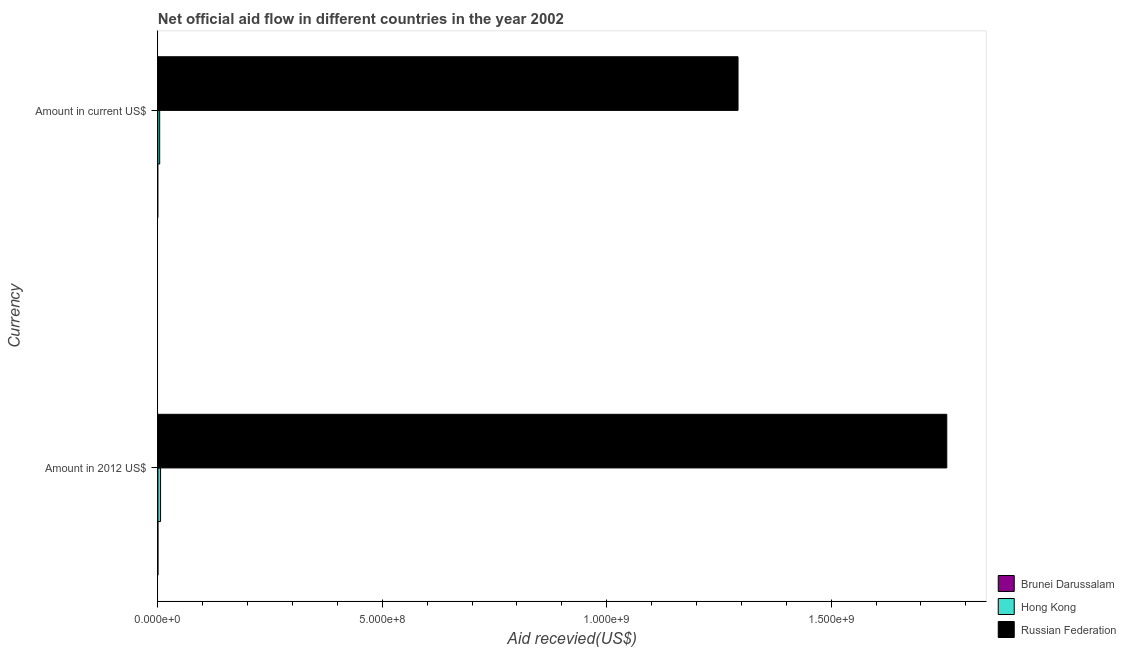What is the label of the 1st group of bars from the top?
Give a very brief answer. Amount in current US$. What is the amount of aid received(expressed in us$) in Brunei Darussalam?
Ensure brevity in your answer.  0. Across all countries, what is the maximum amount of aid received(expressed in us$)?
Ensure brevity in your answer.  1.29e+09. Across all countries, what is the minimum amount of aid received(expressed in 2012 us$)?
Provide a short and direct response. 0. In which country was the amount of aid received(expressed in 2012 us$) maximum?
Your response must be concise. Russian Federation. What is the total amount of aid received(expressed in us$) in the graph?
Make the answer very short. 1.30e+09. What is the difference between the amount of aid received(expressed in 2012 us$) in Hong Kong and that in Russian Federation?
Provide a succinct answer. -1.75e+09. What is the difference between the amount of aid received(expressed in us$) in Hong Kong and the amount of aid received(expressed in 2012 us$) in Russian Federation?
Offer a terse response. -1.75e+09. What is the average amount of aid received(expressed in us$) per country?
Your answer should be very brief. 4.32e+08. What is the difference between the amount of aid received(expressed in 2012 us$) and amount of aid received(expressed in us$) in Hong Kong?
Provide a succinct answer. 1.96e+06. What is the ratio of the amount of aid received(expressed in us$) in Hong Kong to that in Russian Federation?
Keep it short and to the point. 0. In how many countries, is the amount of aid received(expressed in 2012 us$) greater than the average amount of aid received(expressed in 2012 us$) taken over all countries?
Provide a short and direct response. 1. Are all the bars in the graph horizontal?
Provide a short and direct response. Yes. Are the values on the major ticks of X-axis written in scientific E-notation?
Your response must be concise. Yes. Does the graph contain any zero values?
Make the answer very short. Yes. Does the graph contain grids?
Keep it short and to the point. No. How many legend labels are there?
Ensure brevity in your answer.  3. How are the legend labels stacked?
Your answer should be very brief. Vertical. What is the title of the graph?
Provide a succinct answer. Net official aid flow in different countries in the year 2002. Does "Bhutan" appear as one of the legend labels in the graph?
Offer a terse response. No. What is the label or title of the X-axis?
Keep it short and to the point. Aid recevied(US$). What is the label or title of the Y-axis?
Keep it short and to the point. Currency. What is the Aid recevied(US$) in Brunei Darussalam in Amount in 2012 US$?
Your answer should be compact. 0. What is the Aid recevied(US$) in Hong Kong in Amount in 2012 US$?
Offer a very short reply. 5.92e+06. What is the Aid recevied(US$) in Russian Federation in Amount in 2012 US$?
Give a very brief answer. 1.76e+09. What is the Aid recevied(US$) in Hong Kong in Amount in current US$?
Provide a short and direct response. 3.96e+06. What is the Aid recevied(US$) of Russian Federation in Amount in current US$?
Offer a terse response. 1.29e+09. Across all Currency, what is the maximum Aid recevied(US$) in Hong Kong?
Your answer should be very brief. 5.92e+06. Across all Currency, what is the maximum Aid recevied(US$) of Russian Federation?
Offer a very short reply. 1.76e+09. Across all Currency, what is the minimum Aid recevied(US$) in Hong Kong?
Your answer should be very brief. 3.96e+06. Across all Currency, what is the minimum Aid recevied(US$) in Russian Federation?
Your answer should be very brief. 1.29e+09. What is the total Aid recevied(US$) of Hong Kong in the graph?
Offer a terse response. 9.88e+06. What is the total Aid recevied(US$) of Russian Federation in the graph?
Offer a terse response. 3.05e+09. What is the difference between the Aid recevied(US$) of Hong Kong in Amount in 2012 US$ and that in Amount in current US$?
Offer a very short reply. 1.96e+06. What is the difference between the Aid recevied(US$) in Russian Federation in Amount in 2012 US$ and that in Amount in current US$?
Your answer should be compact. 4.65e+08. What is the difference between the Aid recevied(US$) of Hong Kong in Amount in 2012 US$ and the Aid recevied(US$) of Russian Federation in Amount in current US$?
Ensure brevity in your answer.  -1.29e+09. What is the average Aid recevied(US$) of Hong Kong per Currency?
Provide a succinct answer. 4.94e+06. What is the average Aid recevied(US$) in Russian Federation per Currency?
Provide a short and direct response. 1.53e+09. What is the difference between the Aid recevied(US$) of Hong Kong and Aid recevied(US$) of Russian Federation in Amount in 2012 US$?
Your answer should be very brief. -1.75e+09. What is the difference between the Aid recevied(US$) of Hong Kong and Aid recevied(US$) of Russian Federation in Amount in current US$?
Your response must be concise. -1.29e+09. What is the ratio of the Aid recevied(US$) of Hong Kong in Amount in 2012 US$ to that in Amount in current US$?
Your answer should be compact. 1.49. What is the ratio of the Aid recevied(US$) in Russian Federation in Amount in 2012 US$ to that in Amount in current US$?
Provide a succinct answer. 1.36. What is the difference between the highest and the second highest Aid recevied(US$) of Hong Kong?
Make the answer very short. 1.96e+06. What is the difference between the highest and the second highest Aid recevied(US$) in Russian Federation?
Provide a succinct answer. 4.65e+08. What is the difference between the highest and the lowest Aid recevied(US$) in Hong Kong?
Your answer should be very brief. 1.96e+06. What is the difference between the highest and the lowest Aid recevied(US$) in Russian Federation?
Your answer should be compact. 4.65e+08. 